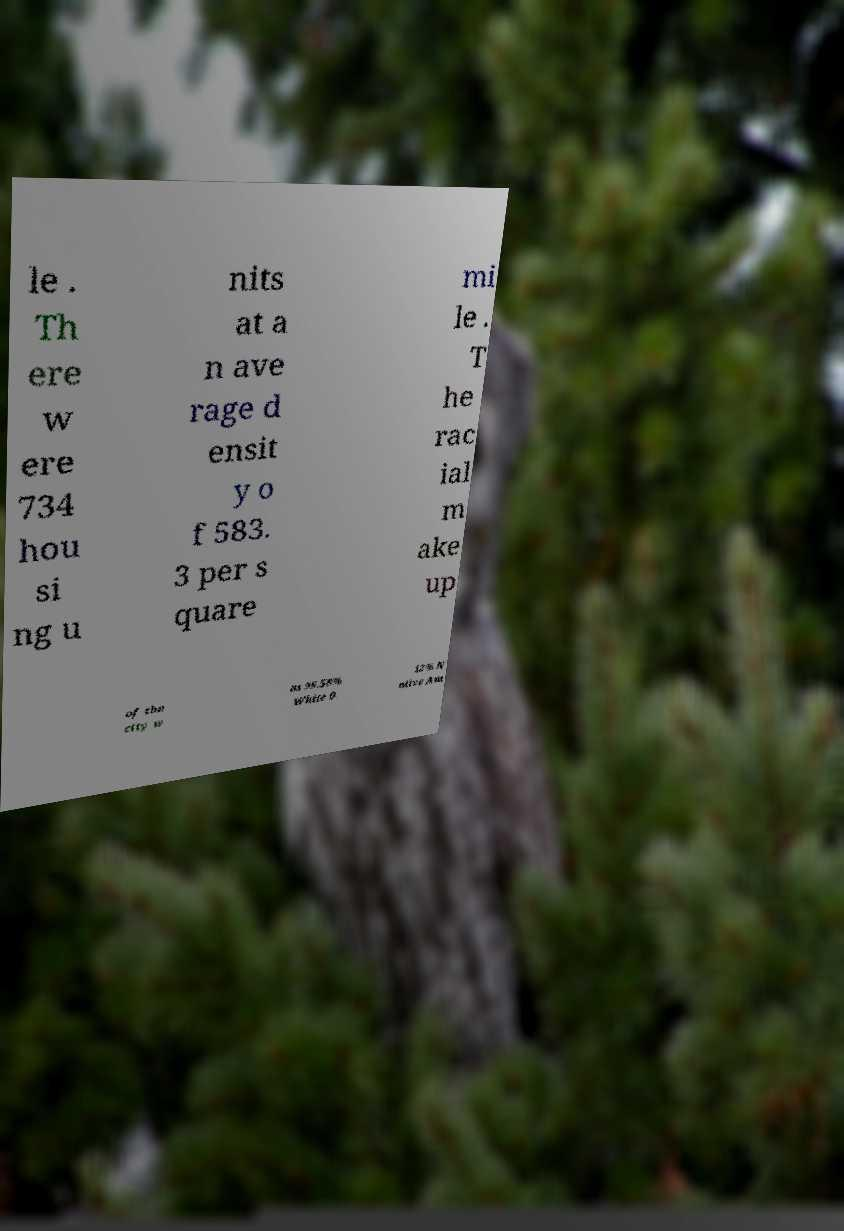Please identify and transcribe the text found in this image. le . Th ere w ere 734 hou si ng u nits at a n ave rage d ensit y o f 583. 3 per s quare mi le . T he rac ial m ake up of the city w as 99.58% White 0. 12% N ative Am 